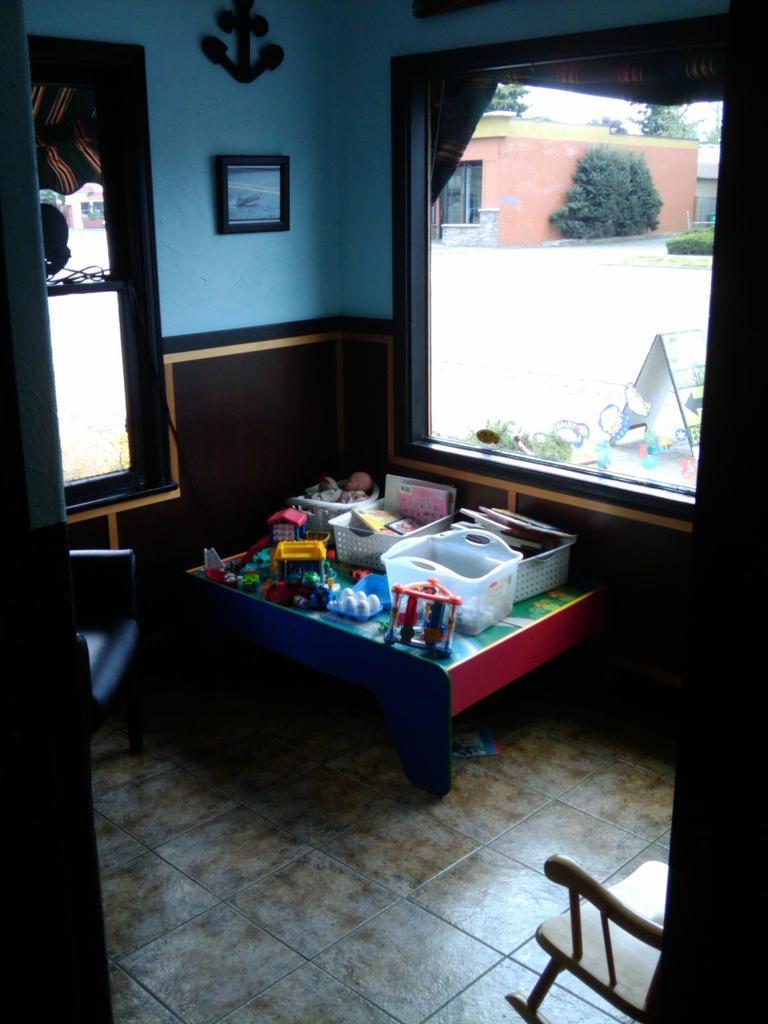In one or two sentences, can you explain what this image depicts? In this image I can see a table with a basket and other objects on it. I can also see there is a photo on a wall, a window and a chair on the floor. 